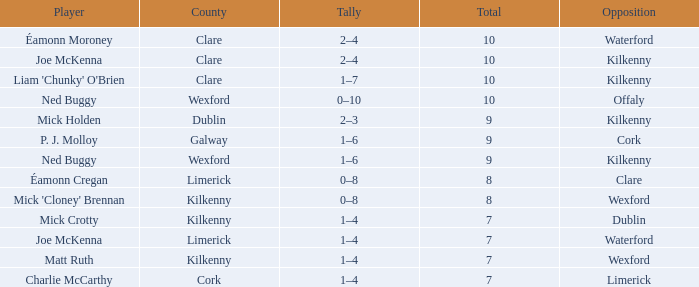Would you mind parsing the complete table? {'header': ['Player', 'County', 'Tally', 'Total', 'Opposition'], 'rows': [['Éamonn Moroney', 'Clare', '2–4', '10', 'Waterford'], ['Joe McKenna', 'Clare', '2–4', '10', 'Kilkenny'], ["Liam 'Chunky' O'Brien", 'Clare', '1–7', '10', 'Kilkenny'], ['Ned Buggy', 'Wexford', '0–10', '10', 'Offaly'], ['Mick Holden', 'Dublin', '2–3', '9', 'Kilkenny'], ['P. J. Molloy', 'Galway', '1–6', '9', 'Cork'], ['Ned Buggy', 'Wexford', '1–6', '9', 'Kilkenny'], ['Éamonn Cregan', 'Limerick', '0–8', '8', 'Clare'], ["Mick 'Cloney' Brennan", 'Kilkenny', '0–8', '8', 'Wexford'], ['Mick Crotty', 'Kilkenny', '1–4', '7', 'Dublin'], ['Joe McKenna', 'Limerick', '1–4', '7', 'Waterford'], ['Matt Ruth', 'Kilkenny', '1–4', '7', 'Wexford'], ['Charlie McCarthy', 'Cork', '1–4', '7', 'Limerick']]} Which Total has a County of kilkenny, and a Tally of 1–4, and a Rank larger than 10? None. 